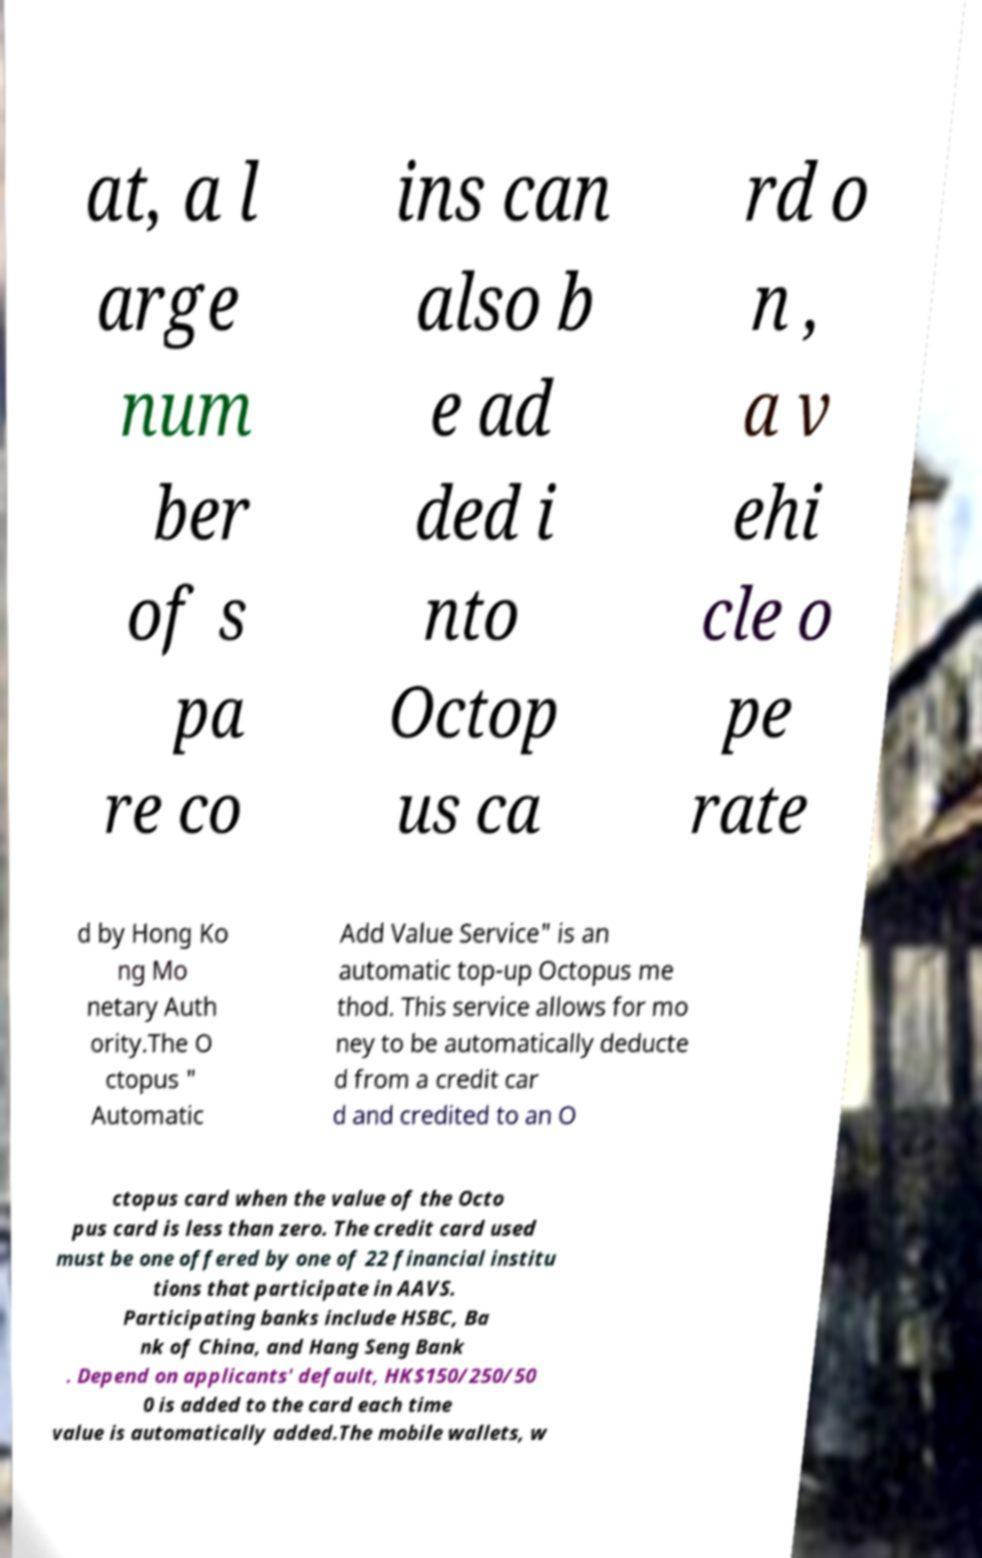For documentation purposes, I need the text within this image transcribed. Could you provide that? at, a l arge num ber of s pa re co ins can also b e ad ded i nto Octop us ca rd o n , a v ehi cle o pe rate d by Hong Ko ng Mo netary Auth ority.The O ctopus " Automatic Add Value Service" is an automatic top-up Octopus me thod. This service allows for mo ney to be automatically deducte d from a credit car d and credited to an O ctopus card when the value of the Octo pus card is less than zero. The credit card used must be one offered by one of 22 financial institu tions that participate in AAVS. Participating banks include HSBC, Ba nk of China, and Hang Seng Bank . Depend on applicants' default, HK$150/250/50 0 is added to the card each time value is automatically added.The mobile wallets, w 